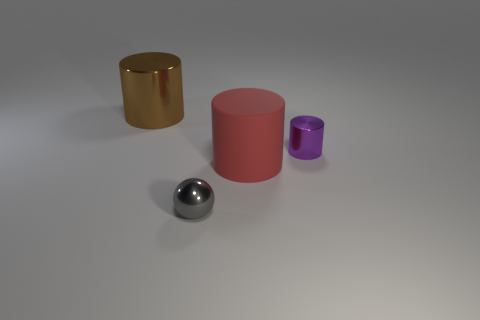Is there a big metal cylinder that has the same color as the large matte thing?
Keep it short and to the point. No. Do the red thing and the gray object have the same size?
Your response must be concise. No. There is a metal cylinder right of the metallic cylinder that is behind the purple metal cylinder; how big is it?
Provide a short and direct response. Small. What is the size of the thing that is in front of the tiny purple metal object and on the right side of the ball?
Give a very brief answer. Large. What number of red things have the same size as the brown metal cylinder?
Your response must be concise. 1. How many shiny things are gray spheres or big things?
Offer a very short reply. 2. What is the large thing in front of the small metallic thing that is behind the gray metallic sphere made of?
Provide a short and direct response. Rubber. How many things are tiny green metal cylinders or large objects in front of the big brown cylinder?
Provide a short and direct response. 1. The purple cylinder that is made of the same material as the brown cylinder is what size?
Your answer should be very brief. Small. How many purple things are big matte cylinders or shiny cubes?
Provide a short and direct response. 0. 